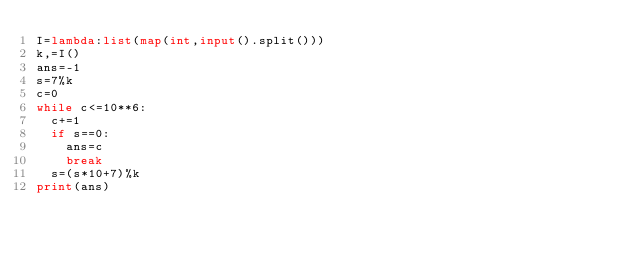Convert code to text. <code><loc_0><loc_0><loc_500><loc_500><_Python_>I=lambda:list(map(int,input().split()))
k,=I()
ans=-1
s=7%k
c=0
while c<=10**6:
	c+=1
	if s==0:
		ans=c
		break
	s=(s*10+7)%k
print(ans)</code> 